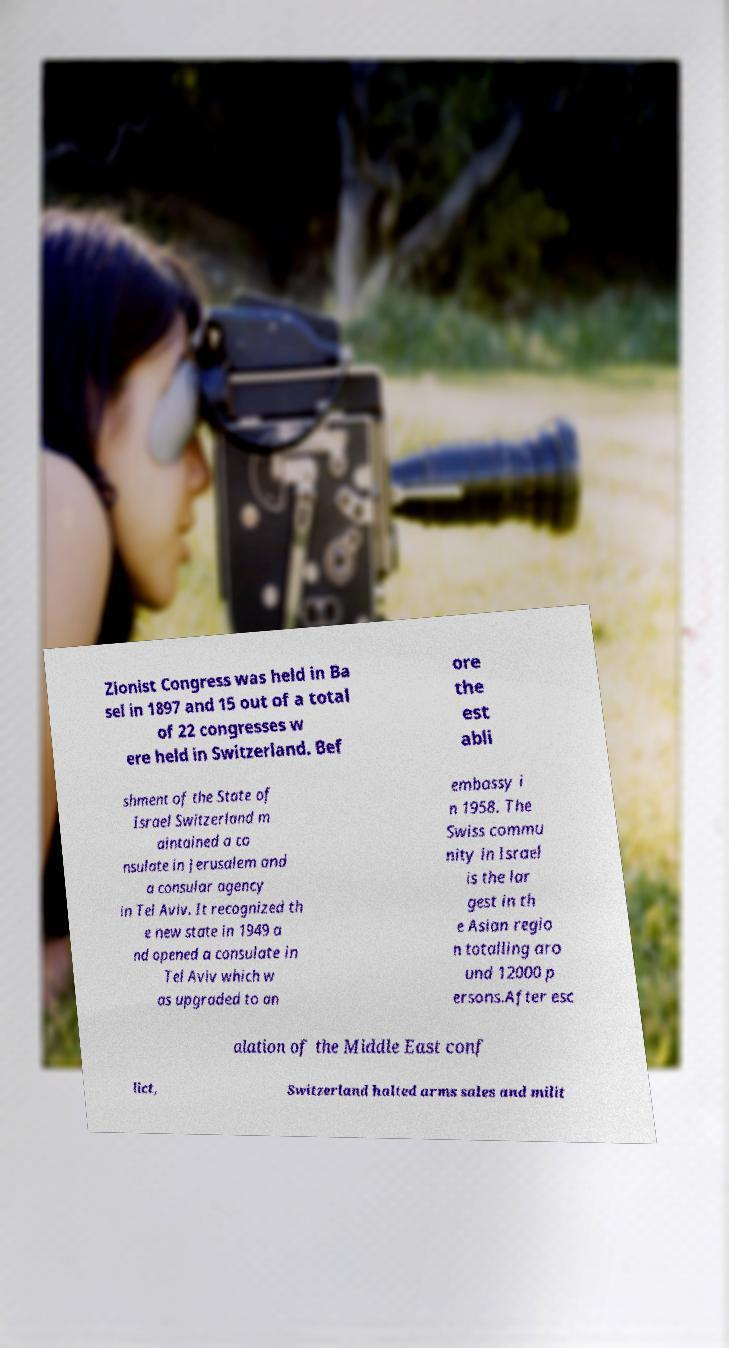Please identify and transcribe the text found in this image. Zionist Congress was held in Ba sel in 1897 and 15 out of a total of 22 congresses w ere held in Switzerland. Bef ore the est abli shment of the State of Israel Switzerland m aintained a co nsulate in Jerusalem and a consular agency in Tel Aviv. It recognized th e new state in 1949 a nd opened a consulate in Tel Aviv which w as upgraded to an embassy i n 1958. The Swiss commu nity in Israel is the lar gest in th e Asian regio n totalling aro und 12000 p ersons.After esc alation of the Middle East conf lict, Switzerland halted arms sales and milit 